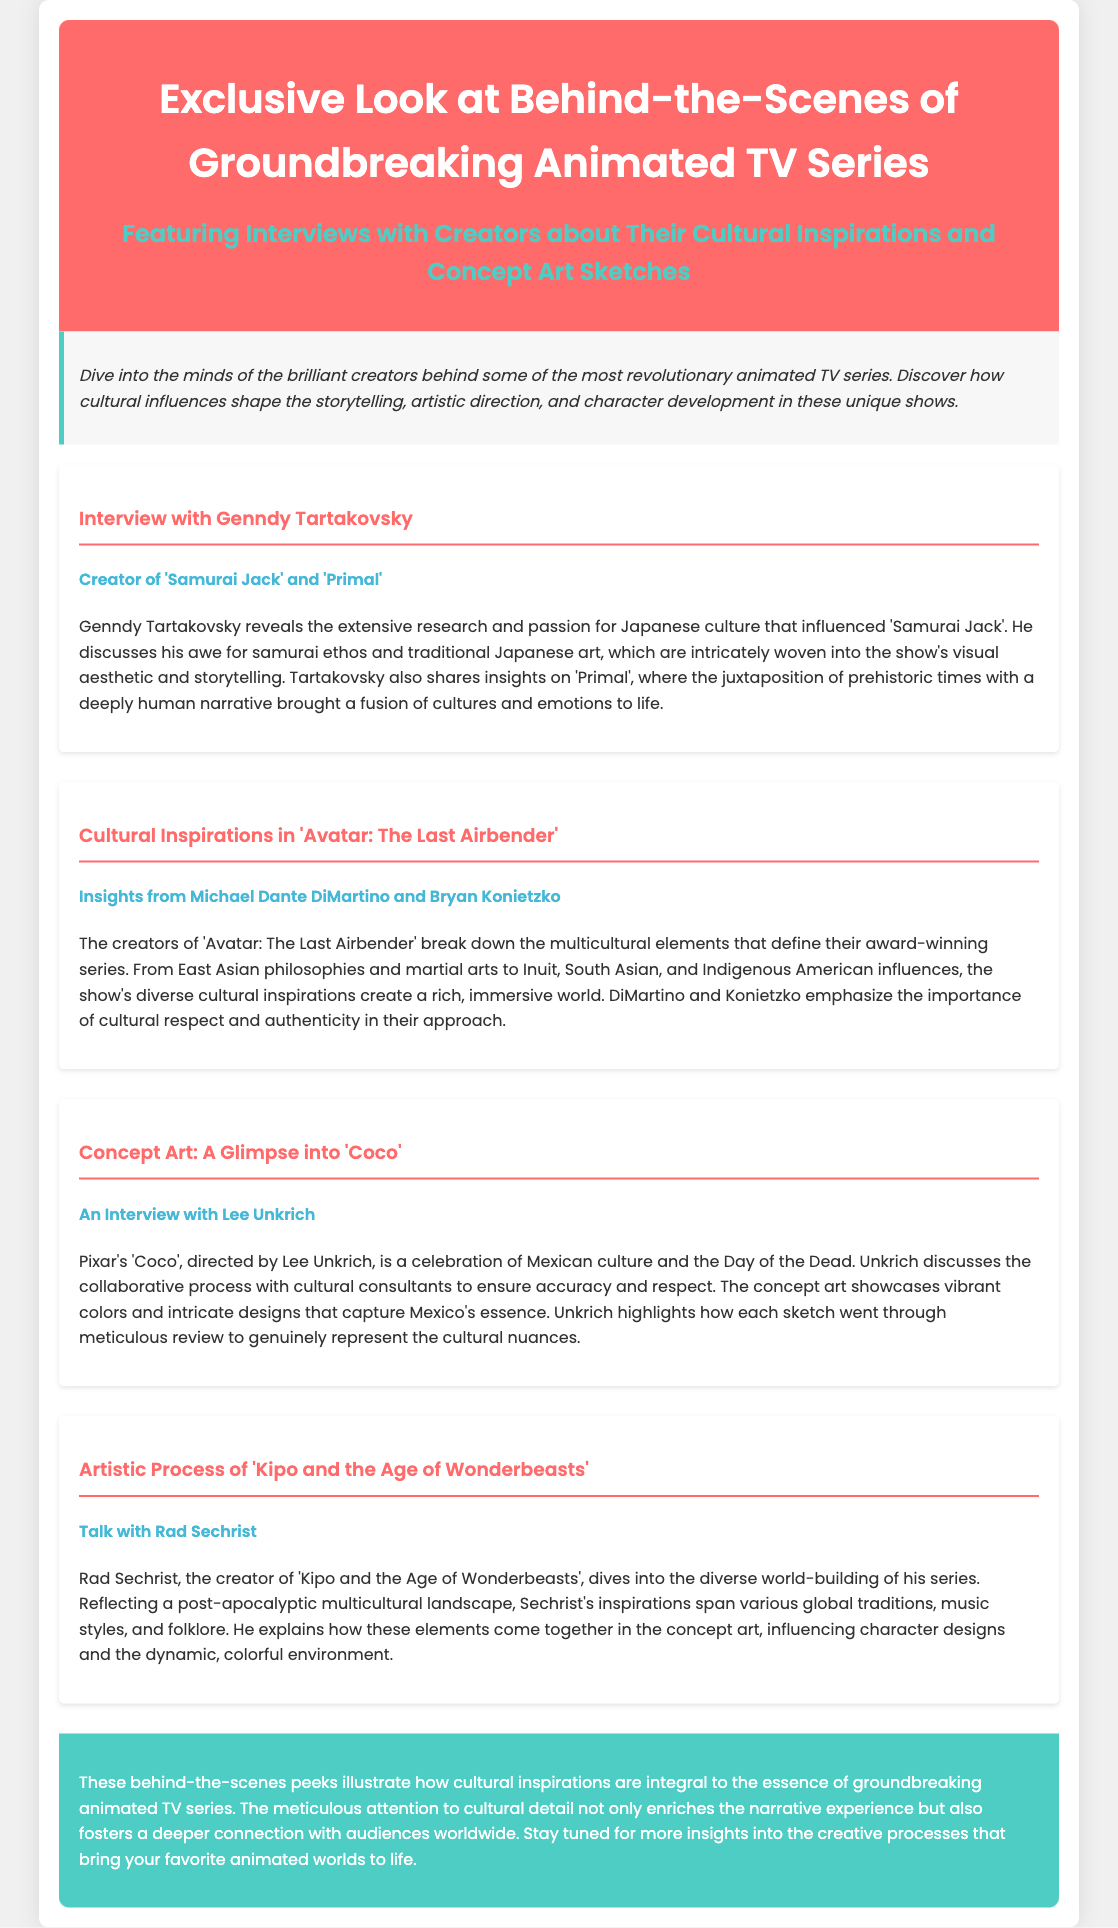What is the title of the series discussed in the document? The title is stated at the beginning of the document in the header section.
Answer: Exclusive Look at Behind-the-Scenes of Groundbreaking Animated TV Series Who is the creator of 'Samurai Jack'? A specific section details the creator of 'Samurai Jack.'
Answer: Genndy Tartakovsky Which animated series features multicultural elements discussed by DiMartino and Konietzko? The text describes this series in the section about cultural inspirations.
Answer: Avatar: The Last Airbender What is the cultural celebration depicted in Pixar's 'Coco'? This information is provided in the section discussing the concept art of 'Coco.'
Answer: Day of the Dead Who directed the animated film 'Coco'? The document explicitly states this information in the section dedicated to 'Coco.'
Answer: Lee Unkrich What type of music styles influenced 'Kipo and the Age of Wonderbeasts'? The document implies a broad range of influences discussed by Rad Sechrist related to music.
Answer: Diverse global traditions What theme is highlighted in the final conclusion of the document? The conclusion summarizes the main theme of cultural details in animated series.
Answer: Cultural inspirations What is the color theme of the header background? The document specifies this in the header styling section.
Answer: Red How does Genndy Tartakovsky feel about samurai culture? This is mentioned in the interview section with Genndy Tartakovsky.
Answer: Awe 